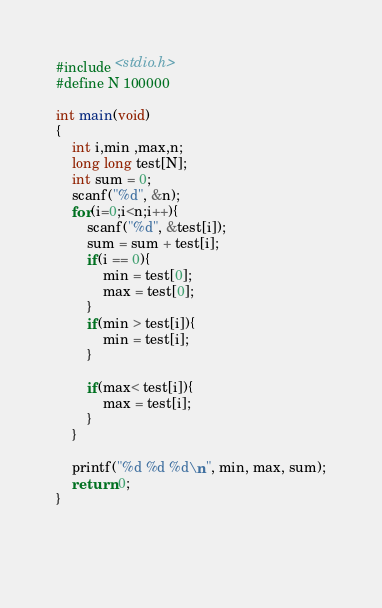<code> <loc_0><loc_0><loc_500><loc_500><_C_>#include <stdio.h>
#define N 100000

int main(void)
{
	int i,min ,max,n;
	long long test[N];
	int sum = 0;
	scanf("%d", &n);
  	for(i=0;i<n;i++){
   		scanf("%d", &test[i]);
     	sum = sum + test[i];
		if(i == 0){
			min = test[0];
			max = test[0];
		}
		if(min > test[i]){
			min = test[i];
        }
 		
		if(max< test[i]){
			max = test[i];
		}
	}
	
	printf("%d %d %d\n", min, max, sum);
    return 0;
}
	
    	
  </code> 